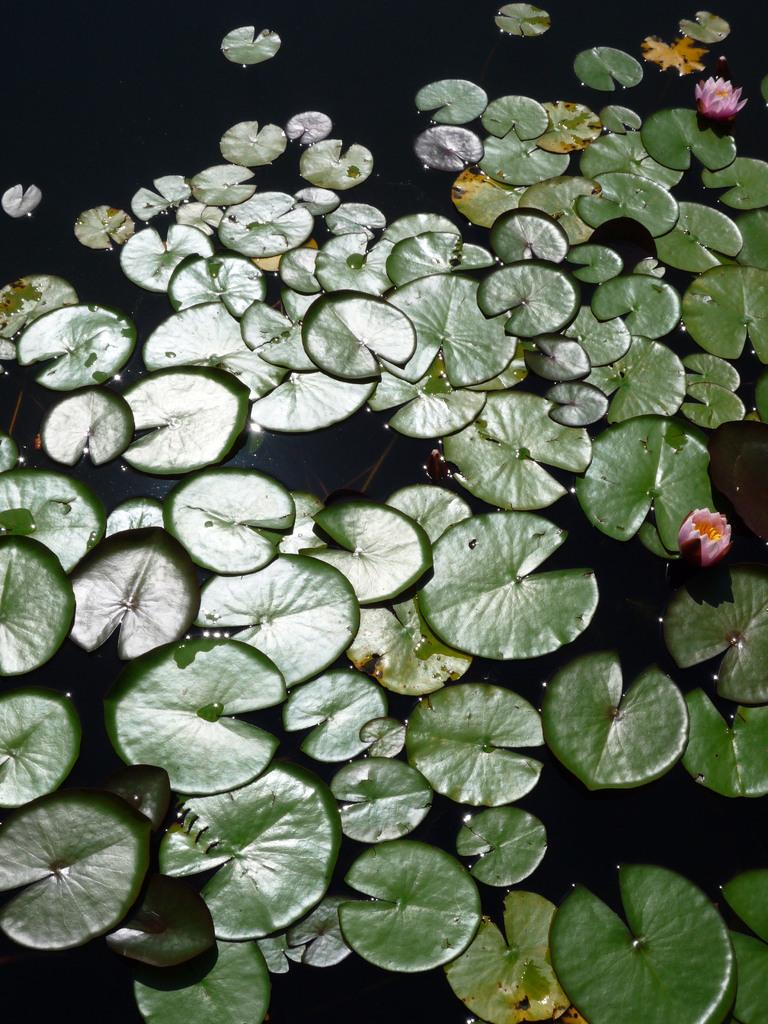What type of plants can be seen in the image? There are flowers and leaves in the image. Where are the flowers and leaves located? The flowers and leaves are on the water. How many men are seen picking berries in the image? There are no men or berries present in the image; it features flowers and leaves on the water. 